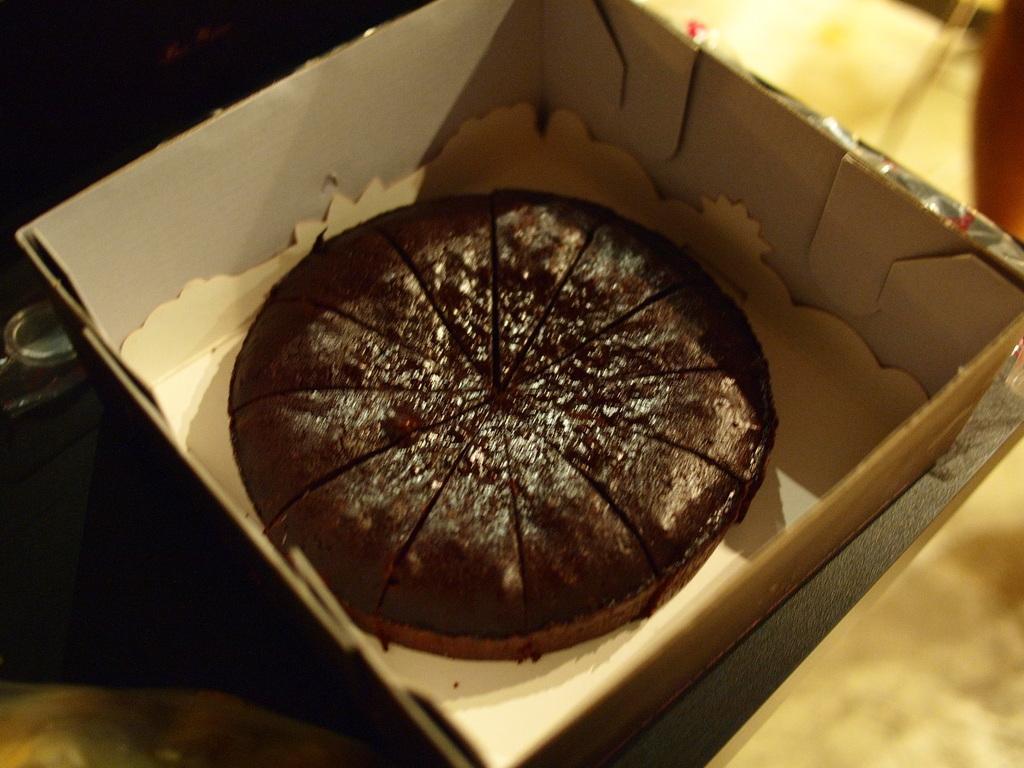Describe this image in one or two sentences. In this image I see a box in which there is a cake which is of dark brown in color and I see it is dark over here and this box is on the cream color surface. 